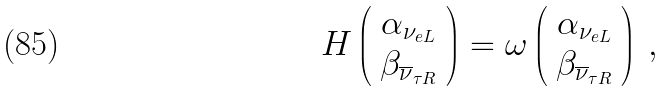<formula> <loc_0><loc_0><loc_500><loc_500>H \left ( \begin{array} { c } \alpha _ { \nu _ { e L } } \\ \beta _ { \overline { \nu } _ { \tau R } } \end{array} \right ) = \omega \left ( \begin{array} { c } \alpha _ { \nu _ { e L } } \\ \beta _ { \overline { \nu } _ { \tau R } } \end{array} \right ) \, ,</formula> 